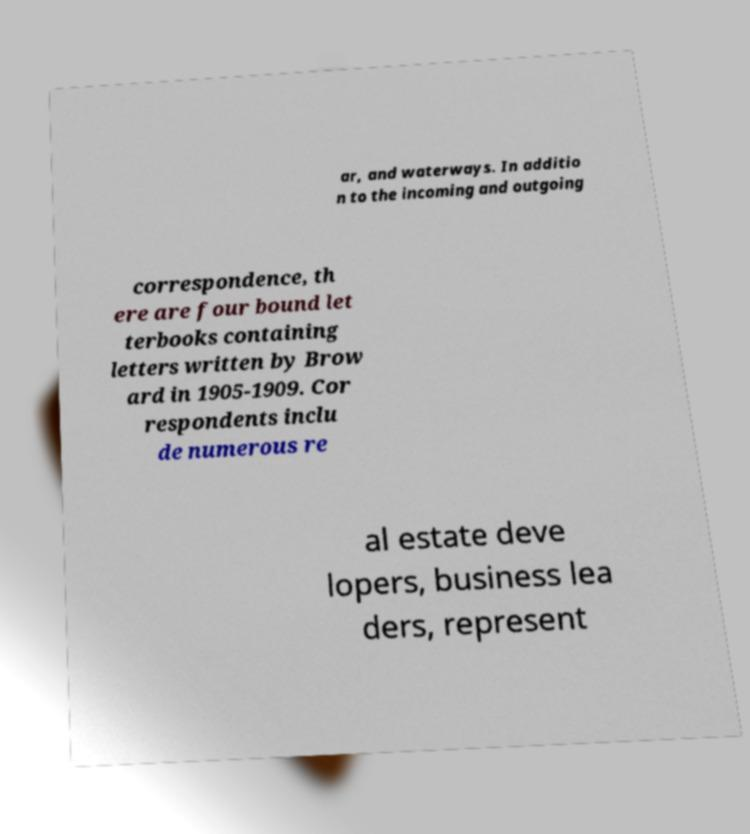Can you accurately transcribe the text from the provided image for me? ar, and waterways. In additio n to the incoming and outgoing correspondence, th ere are four bound let terbooks containing letters written by Brow ard in 1905-1909. Cor respondents inclu de numerous re al estate deve lopers, business lea ders, represent 